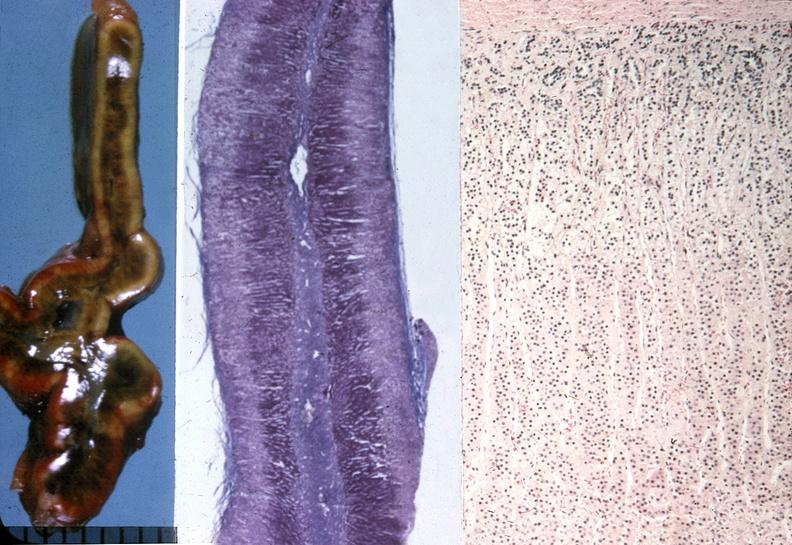where does this belong to?
Answer the question using a single word or phrase. Endocrine system 